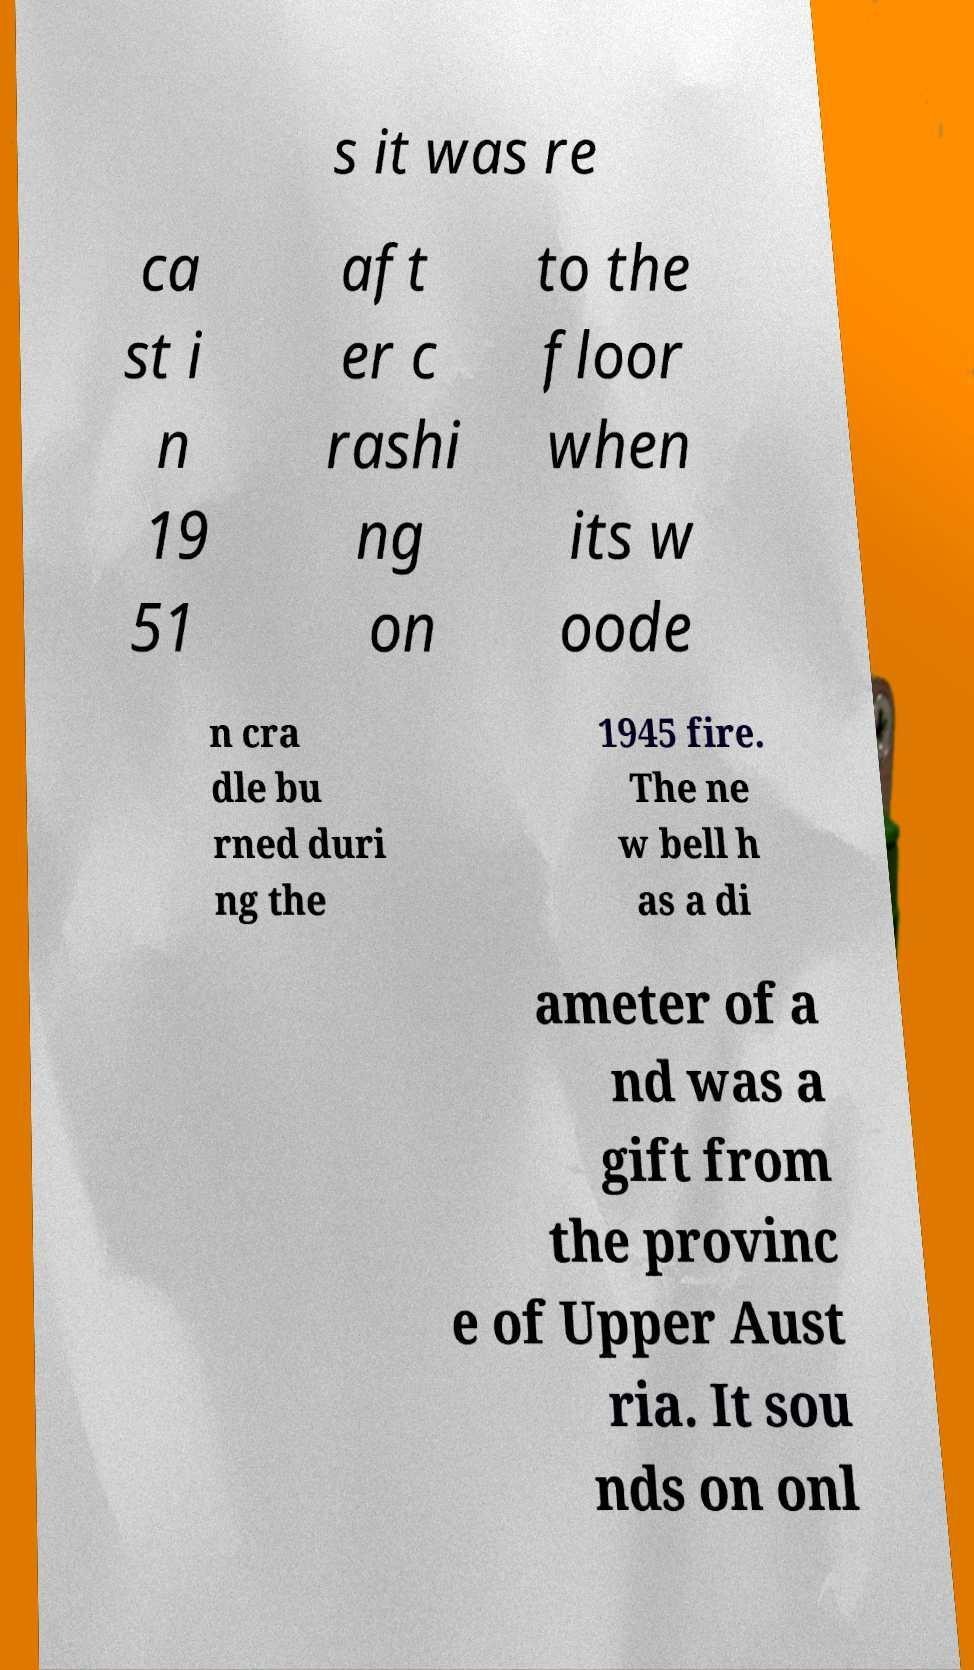Please read and relay the text visible in this image. What does it say? s it was re ca st i n 19 51 aft er c rashi ng on to the floor when its w oode n cra dle bu rned duri ng the 1945 fire. The ne w bell h as a di ameter of a nd was a gift from the provinc e of Upper Aust ria. It sou nds on onl 